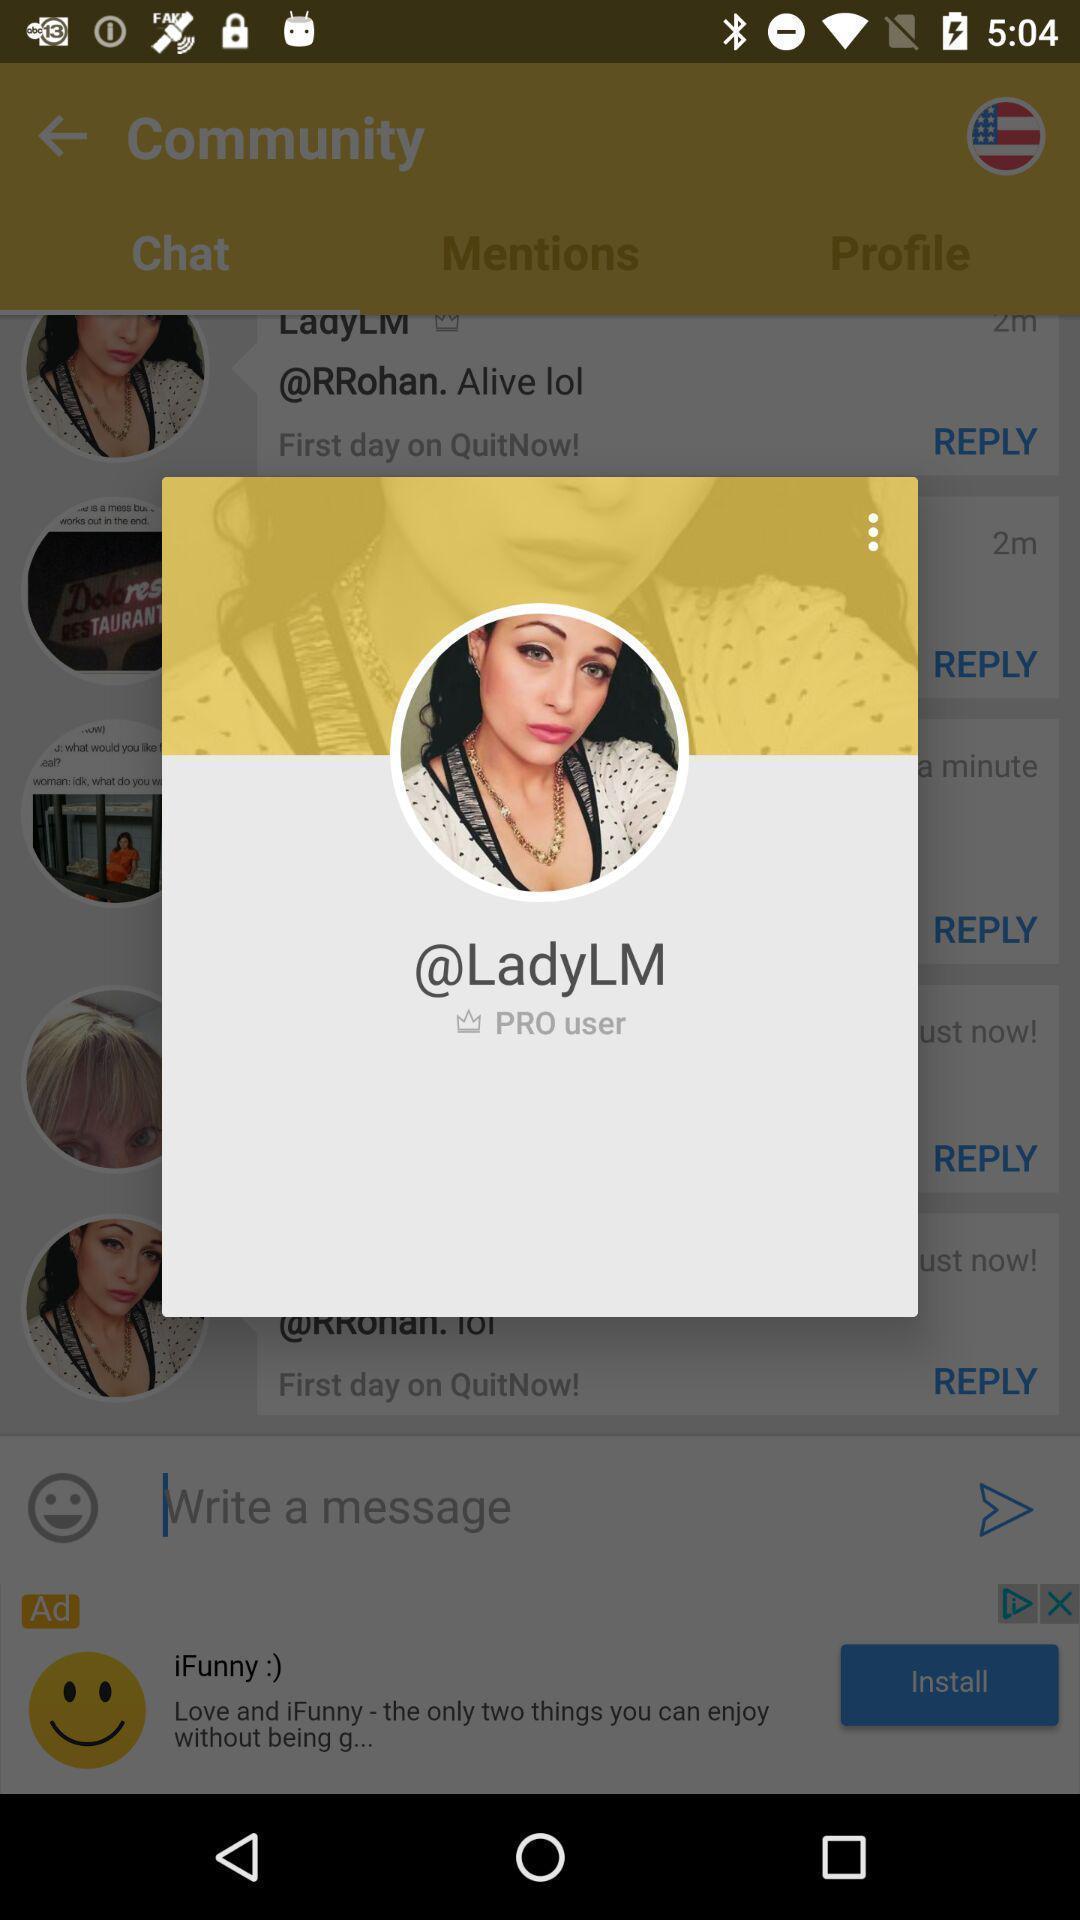Describe the visual elements of this screenshot. Pop-up showing profile picture in a social app. 